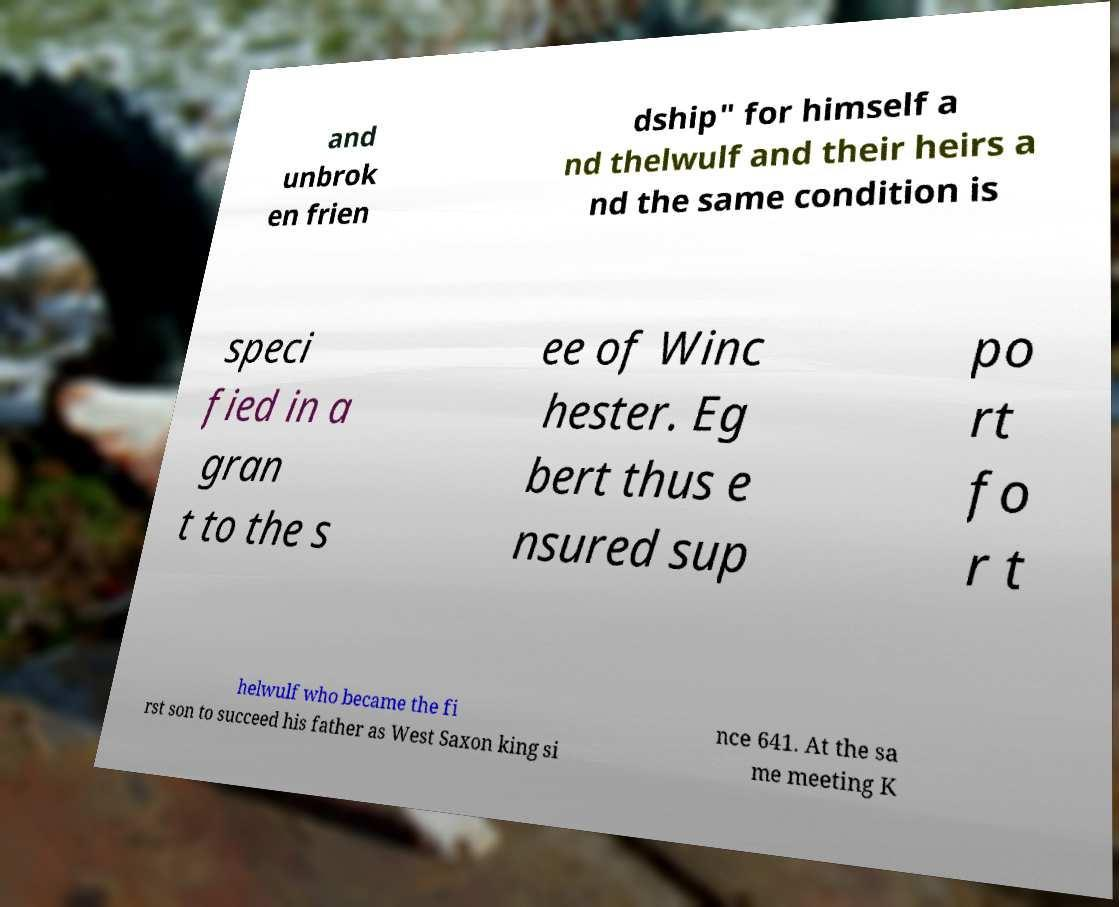Please read and relay the text visible in this image. What does it say? and unbrok en frien dship" for himself a nd thelwulf and their heirs a nd the same condition is speci fied in a gran t to the s ee of Winc hester. Eg bert thus e nsured sup po rt fo r t helwulf who became the fi rst son to succeed his father as West Saxon king si nce 641. At the sa me meeting K 